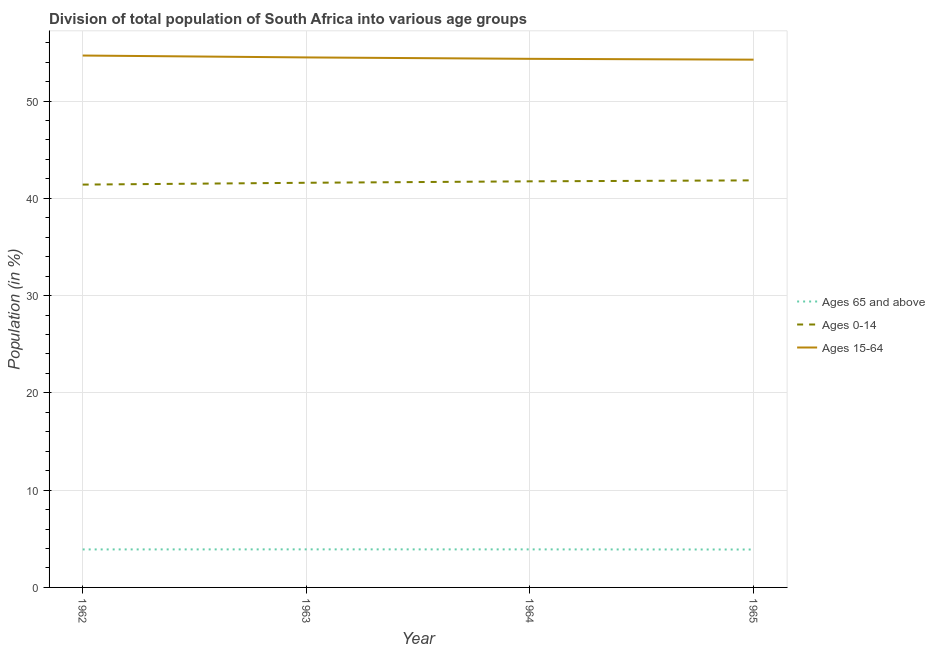Does the line corresponding to percentage of population within the age-group of 65 and above intersect with the line corresponding to percentage of population within the age-group 0-14?
Your response must be concise. No. Is the number of lines equal to the number of legend labels?
Keep it short and to the point. Yes. What is the percentage of population within the age-group 0-14 in 1965?
Provide a short and direct response. 41.85. Across all years, what is the maximum percentage of population within the age-group of 65 and above?
Keep it short and to the point. 3.91. Across all years, what is the minimum percentage of population within the age-group of 65 and above?
Offer a terse response. 3.9. In which year was the percentage of population within the age-group of 65 and above maximum?
Offer a very short reply. 1963. In which year was the percentage of population within the age-group 15-64 minimum?
Provide a succinct answer. 1965. What is the total percentage of population within the age-group 15-64 in the graph?
Your answer should be very brief. 217.77. What is the difference between the percentage of population within the age-group of 65 and above in 1962 and that in 1963?
Keep it short and to the point. -0.01. What is the difference between the percentage of population within the age-group 0-14 in 1964 and the percentage of population within the age-group of 65 and above in 1965?
Make the answer very short. 37.85. What is the average percentage of population within the age-group of 65 and above per year?
Give a very brief answer. 3.91. In the year 1963, what is the difference between the percentage of population within the age-group 15-64 and percentage of population within the age-group of 65 and above?
Your answer should be very brief. 50.57. What is the ratio of the percentage of population within the age-group of 65 and above in 1962 to that in 1963?
Make the answer very short. 1. Is the percentage of population within the age-group of 65 and above in 1962 less than that in 1964?
Make the answer very short. Yes. What is the difference between the highest and the second highest percentage of population within the age-group 15-64?
Keep it short and to the point. 0.19. What is the difference between the highest and the lowest percentage of population within the age-group of 65 and above?
Your answer should be compact. 0.02. Is the percentage of population within the age-group 15-64 strictly greater than the percentage of population within the age-group of 65 and above over the years?
Give a very brief answer. Yes. Is the percentage of population within the age-group of 65 and above strictly less than the percentage of population within the age-group 0-14 over the years?
Your answer should be very brief. Yes. What is the difference between two consecutive major ticks on the Y-axis?
Provide a succinct answer. 10. Are the values on the major ticks of Y-axis written in scientific E-notation?
Offer a very short reply. No. Where does the legend appear in the graph?
Provide a short and direct response. Center right. How many legend labels are there?
Offer a terse response. 3. What is the title of the graph?
Offer a very short reply. Division of total population of South Africa into various age groups
. Does "Poland" appear as one of the legend labels in the graph?
Provide a succinct answer. No. What is the label or title of the X-axis?
Make the answer very short. Year. What is the Population (in %) in Ages 65 and above in 1962?
Provide a short and direct response. 3.91. What is the Population (in %) in Ages 0-14 in 1962?
Offer a very short reply. 41.41. What is the Population (in %) in Ages 15-64 in 1962?
Make the answer very short. 54.68. What is the Population (in %) of Ages 65 and above in 1963?
Give a very brief answer. 3.91. What is the Population (in %) in Ages 0-14 in 1963?
Give a very brief answer. 41.6. What is the Population (in %) of Ages 15-64 in 1963?
Ensure brevity in your answer.  54.49. What is the Population (in %) in Ages 65 and above in 1964?
Your answer should be compact. 3.91. What is the Population (in %) in Ages 0-14 in 1964?
Make the answer very short. 41.75. What is the Population (in %) in Ages 15-64 in 1964?
Your answer should be compact. 54.34. What is the Population (in %) in Ages 65 and above in 1965?
Your answer should be compact. 3.9. What is the Population (in %) of Ages 0-14 in 1965?
Your answer should be very brief. 41.85. What is the Population (in %) in Ages 15-64 in 1965?
Offer a terse response. 54.26. Across all years, what is the maximum Population (in %) of Ages 65 and above?
Provide a succinct answer. 3.91. Across all years, what is the maximum Population (in %) in Ages 0-14?
Offer a very short reply. 41.85. Across all years, what is the maximum Population (in %) in Ages 15-64?
Give a very brief answer. 54.68. Across all years, what is the minimum Population (in %) in Ages 65 and above?
Give a very brief answer. 3.9. Across all years, what is the minimum Population (in %) of Ages 0-14?
Your answer should be compact. 41.41. Across all years, what is the minimum Population (in %) of Ages 15-64?
Keep it short and to the point. 54.26. What is the total Population (in %) in Ages 65 and above in the graph?
Provide a short and direct response. 15.63. What is the total Population (in %) in Ages 0-14 in the graph?
Provide a short and direct response. 166.6. What is the total Population (in %) of Ages 15-64 in the graph?
Your answer should be compact. 217.77. What is the difference between the Population (in %) in Ages 65 and above in 1962 and that in 1963?
Your answer should be compact. -0.01. What is the difference between the Population (in %) in Ages 0-14 in 1962 and that in 1963?
Provide a short and direct response. -0.19. What is the difference between the Population (in %) of Ages 15-64 in 1962 and that in 1963?
Provide a succinct answer. 0.19. What is the difference between the Population (in %) of Ages 65 and above in 1962 and that in 1964?
Provide a short and direct response. -0. What is the difference between the Population (in %) in Ages 0-14 in 1962 and that in 1964?
Provide a short and direct response. -0.34. What is the difference between the Population (in %) of Ages 15-64 in 1962 and that in 1964?
Offer a terse response. 0.34. What is the difference between the Population (in %) in Ages 65 and above in 1962 and that in 1965?
Make the answer very short. 0.01. What is the difference between the Population (in %) of Ages 0-14 in 1962 and that in 1965?
Keep it short and to the point. -0.43. What is the difference between the Population (in %) in Ages 15-64 in 1962 and that in 1965?
Provide a succinct answer. 0.43. What is the difference between the Population (in %) in Ages 65 and above in 1963 and that in 1964?
Keep it short and to the point. 0. What is the difference between the Population (in %) in Ages 0-14 in 1963 and that in 1964?
Give a very brief answer. -0.15. What is the difference between the Population (in %) of Ages 15-64 in 1963 and that in 1964?
Your answer should be very brief. 0.14. What is the difference between the Population (in %) of Ages 65 and above in 1963 and that in 1965?
Make the answer very short. 0.02. What is the difference between the Population (in %) in Ages 0-14 in 1963 and that in 1965?
Offer a terse response. -0.25. What is the difference between the Population (in %) of Ages 15-64 in 1963 and that in 1965?
Offer a terse response. 0.23. What is the difference between the Population (in %) of Ages 65 and above in 1964 and that in 1965?
Provide a succinct answer. 0.01. What is the difference between the Population (in %) in Ages 0-14 in 1964 and that in 1965?
Keep it short and to the point. -0.1. What is the difference between the Population (in %) of Ages 15-64 in 1964 and that in 1965?
Your answer should be compact. 0.09. What is the difference between the Population (in %) of Ages 65 and above in 1962 and the Population (in %) of Ages 0-14 in 1963?
Provide a succinct answer. -37.69. What is the difference between the Population (in %) in Ages 65 and above in 1962 and the Population (in %) in Ages 15-64 in 1963?
Ensure brevity in your answer.  -50.58. What is the difference between the Population (in %) of Ages 0-14 in 1962 and the Population (in %) of Ages 15-64 in 1963?
Give a very brief answer. -13.07. What is the difference between the Population (in %) in Ages 65 and above in 1962 and the Population (in %) in Ages 0-14 in 1964?
Make the answer very short. -37.84. What is the difference between the Population (in %) of Ages 65 and above in 1962 and the Population (in %) of Ages 15-64 in 1964?
Your answer should be compact. -50.43. What is the difference between the Population (in %) of Ages 0-14 in 1962 and the Population (in %) of Ages 15-64 in 1964?
Offer a very short reply. -12.93. What is the difference between the Population (in %) of Ages 65 and above in 1962 and the Population (in %) of Ages 0-14 in 1965?
Make the answer very short. -37.94. What is the difference between the Population (in %) in Ages 65 and above in 1962 and the Population (in %) in Ages 15-64 in 1965?
Offer a terse response. -50.35. What is the difference between the Population (in %) in Ages 0-14 in 1962 and the Population (in %) in Ages 15-64 in 1965?
Your response must be concise. -12.84. What is the difference between the Population (in %) in Ages 65 and above in 1963 and the Population (in %) in Ages 0-14 in 1964?
Your answer should be compact. -37.83. What is the difference between the Population (in %) of Ages 65 and above in 1963 and the Population (in %) of Ages 15-64 in 1964?
Give a very brief answer. -50.43. What is the difference between the Population (in %) of Ages 0-14 in 1963 and the Population (in %) of Ages 15-64 in 1964?
Make the answer very short. -12.74. What is the difference between the Population (in %) of Ages 65 and above in 1963 and the Population (in %) of Ages 0-14 in 1965?
Your response must be concise. -37.93. What is the difference between the Population (in %) in Ages 65 and above in 1963 and the Population (in %) in Ages 15-64 in 1965?
Give a very brief answer. -50.34. What is the difference between the Population (in %) of Ages 0-14 in 1963 and the Population (in %) of Ages 15-64 in 1965?
Your answer should be very brief. -12.66. What is the difference between the Population (in %) in Ages 65 and above in 1964 and the Population (in %) in Ages 0-14 in 1965?
Keep it short and to the point. -37.94. What is the difference between the Population (in %) in Ages 65 and above in 1964 and the Population (in %) in Ages 15-64 in 1965?
Make the answer very short. -50.34. What is the difference between the Population (in %) of Ages 0-14 in 1964 and the Population (in %) of Ages 15-64 in 1965?
Offer a very short reply. -12.51. What is the average Population (in %) of Ages 65 and above per year?
Your answer should be very brief. 3.91. What is the average Population (in %) in Ages 0-14 per year?
Offer a very short reply. 41.65. What is the average Population (in %) in Ages 15-64 per year?
Make the answer very short. 54.44. In the year 1962, what is the difference between the Population (in %) in Ages 65 and above and Population (in %) in Ages 0-14?
Give a very brief answer. -37.51. In the year 1962, what is the difference between the Population (in %) of Ages 65 and above and Population (in %) of Ages 15-64?
Offer a terse response. -50.77. In the year 1962, what is the difference between the Population (in %) in Ages 0-14 and Population (in %) in Ages 15-64?
Provide a short and direct response. -13.27. In the year 1963, what is the difference between the Population (in %) in Ages 65 and above and Population (in %) in Ages 0-14?
Make the answer very short. -37.69. In the year 1963, what is the difference between the Population (in %) of Ages 65 and above and Population (in %) of Ages 15-64?
Ensure brevity in your answer.  -50.57. In the year 1963, what is the difference between the Population (in %) of Ages 0-14 and Population (in %) of Ages 15-64?
Your answer should be compact. -12.89. In the year 1964, what is the difference between the Population (in %) in Ages 65 and above and Population (in %) in Ages 0-14?
Ensure brevity in your answer.  -37.84. In the year 1964, what is the difference between the Population (in %) of Ages 65 and above and Population (in %) of Ages 15-64?
Ensure brevity in your answer.  -50.43. In the year 1964, what is the difference between the Population (in %) of Ages 0-14 and Population (in %) of Ages 15-64?
Ensure brevity in your answer.  -12.59. In the year 1965, what is the difference between the Population (in %) of Ages 65 and above and Population (in %) of Ages 0-14?
Provide a short and direct response. -37.95. In the year 1965, what is the difference between the Population (in %) in Ages 65 and above and Population (in %) in Ages 15-64?
Give a very brief answer. -50.36. In the year 1965, what is the difference between the Population (in %) of Ages 0-14 and Population (in %) of Ages 15-64?
Keep it short and to the point. -12.41. What is the ratio of the Population (in %) of Ages 65 and above in 1962 to that in 1964?
Offer a very short reply. 1. What is the ratio of the Population (in %) of Ages 0-14 in 1962 to that in 1964?
Your response must be concise. 0.99. What is the ratio of the Population (in %) of Ages 0-14 in 1963 to that in 1965?
Offer a terse response. 0.99. What is the difference between the highest and the second highest Population (in %) in Ages 65 and above?
Offer a very short reply. 0. What is the difference between the highest and the second highest Population (in %) in Ages 0-14?
Provide a succinct answer. 0.1. What is the difference between the highest and the second highest Population (in %) of Ages 15-64?
Give a very brief answer. 0.19. What is the difference between the highest and the lowest Population (in %) of Ages 65 and above?
Keep it short and to the point. 0.02. What is the difference between the highest and the lowest Population (in %) in Ages 0-14?
Your response must be concise. 0.43. What is the difference between the highest and the lowest Population (in %) in Ages 15-64?
Ensure brevity in your answer.  0.43. 